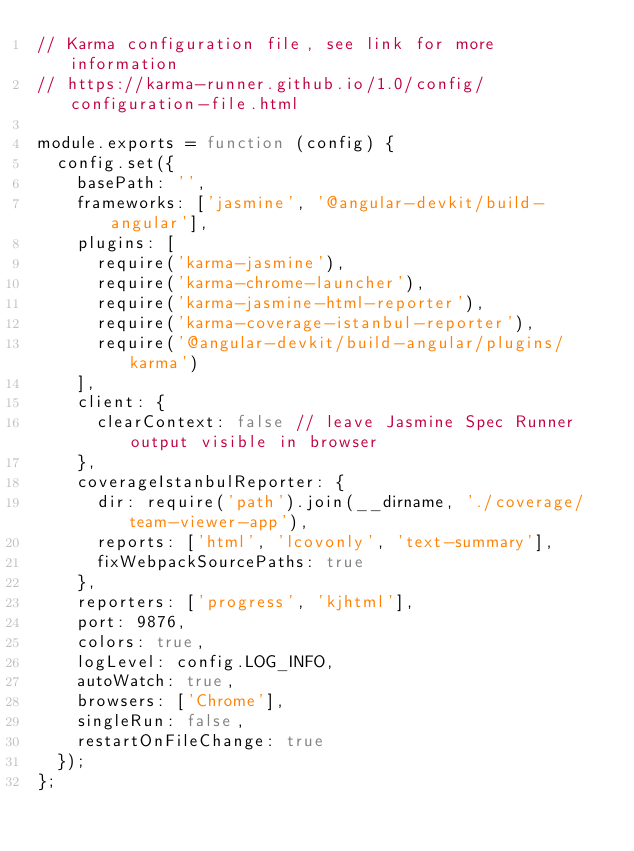<code> <loc_0><loc_0><loc_500><loc_500><_JavaScript_>// Karma configuration file, see link for more information
// https://karma-runner.github.io/1.0/config/configuration-file.html

module.exports = function (config) {
  config.set({
    basePath: '',
    frameworks: ['jasmine', '@angular-devkit/build-angular'],
    plugins: [
      require('karma-jasmine'),
      require('karma-chrome-launcher'),
      require('karma-jasmine-html-reporter'),
      require('karma-coverage-istanbul-reporter'),
      require('@angular-devkit/build-angular/plugins/karma')
    ],
    client: {
      clearContext: false // leave Jasmine Spec Runner output visible in browser
    },
    coverageIstanbulReporter: {
      dir: require('path').join(__dirname, './coverage/team-viewer-app'),
      reports: ['html', 'lcovonly', 'text-summary'],
      fixWebpackSourcePaths: true
    },
    reporters: ['progress', 'kjhtml'],
    port: 9876,
    colors: true,
    logLevel: config.LOG_INFO,
    autoWatch: true,
    browsers: ['Chrome'],
    singleRun: false,
    restartOnFileChange: true
  });
};
</code> 